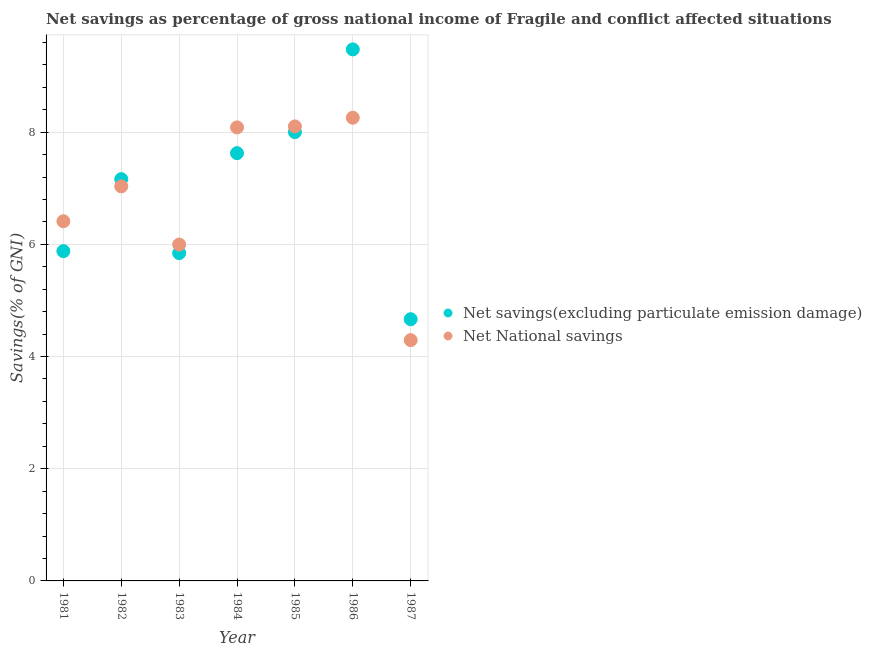Is the number of dotlines equal to the number of legend labels?
Offer a very short reply. Yes. What is the net savings(excluding particulate emission damage) in 1987?
Your answer should be compact. 4.67. Across all years, what is the maximum net savings(excluding particulate emission damage)?
Ensure brevity in your answer.  9.48. Across all years, what is the minimum net savings(excluding particulate emission damage)?
Provide a succinct answer. 4.67. In which year was the net national savings maximum?
Make the answer very short. 1986. In which year was the net national savings minimum?
Give a very brief answer. 1987. What is the total net savings(excluding particulate emission damage) in the graph?
Keep it short and to the point. 48.66. What is the difference between the net national savings in 1986 and that in 1987?
Offer a terse response. 3.96. What is the difference between the net national savings in 1986 and the net savings(excluding particulate emission damage) in 1984?
Keep it short and to the point. 0.63. What is the average net savings(excluding particulate emission damage) per year?
Offer a terse response. 6.95. In the year 1985, what is the difference between the net savings(excluding particulate emission damage) and net national savings?
Offer a terse response. -0.1. What is the ratio of the net national savings in 1981 to that in 1985?
Your answer should be very brief. 0.79. Is the difference between the net savings(excluding particulate emission damage) in 1982 and 1985 greater than the difference between the net national savings in 1982 and 1985?
Your answer should be compact. Yes. What is the difference between the highest and the second highest net savings(excluding particulate emission damage)?
Keep it short and to the point. 1.47. What is the difference between the highest and the lowest net savings(excluding particulate emission damage)?
Keep it short and to the point. 4.81. In how many years, is the net national savings greater than the average net national savings taken over all years?
Offer a very short reply. 4. Is the sum of the net savings(excluding particulate emission damage) in 1982 and 1984 greater than the maximum net national savings across all years?
Your answer should be compact. Yes. Does the net national savings monotonically increase over the years?
Offer a terse response. No. Is the net national savings strictly greater than the net savings(excluding particulate emission damage) over the years?
Make the answer very short. No. Is the net national savings strictly less than the net savings(excluding particulate emission damage) over the years?
Make the answer very short. No. How many dotlines are there?
Offer a very short reply. 2. How many years are there in the graph?
Your answer should be very brief. 7. Where does the legend appear in the graph?
Keep it short and to the point. Center right. How are the legend labels stacked?
Give a very brief answer. Vertical. What is the title of the graph?
Your answer should be compact. Net savings as percentage of gross national income of Fragile and conflict affected situations. Does "Residents" appear as one of the legend labels in the graph?
Ensure brevity in your answer.  No. What is the label or title of the X-axis?
Your answer should be compact. Year. What is the label or title of the Y-axis?
Ensure brevity in your answer.  Savings(% of GNI). What is the Savings(% of GNI) of Net savings(excluding particulate emission damage) in 1981?
Provide a succinct answer. 5.88. What is the Savings(% of GNI) in Net National savings in 1981?
Make the answer very short. 6.41. What is the Savings(% of GNI) of Net savings(excluding particulate emission damage) in 1982?
Provide a short and direct response. 7.16. What is the Savings(% of GNI) in Net National savings in 1982?
Offer a terse response. 7.03. What is the Savings(% of GNI) in Net savings(excluding particulate emission damage) in 1983?
Offer a terse response. 5.84. What is the Savings(% of GNI) of Net National savings in 1983?
Your response must be concise. 6. What is the Savings(% of GNI) of Net savings(excluding particulate emission damage) in 1984?
Give a very brief answer. 7.63. What is the Savings(% of GNI) in Net National savings in 1984?
Your answer should be compact. 8.09. What is the Savings(% of GNI) of Net savings(excluding particulate emission damage) in 1985?
Your answer should be compact. 8. What is the Savings(% of GNI) in Net National savings in 1985?
Provide a short and direct response. 8.1. What is the Savings(% of GNI) of Net savings(excluding particulate emission damage) in 1986?
Provide a short and direct response. 9.48. What is the Savings(% of GNI) of Net National savings in 1986?
Your response must be concise. 8.26. What is the Savings(% of GNI) of Net savings(excluding particulate emission damage) in 1987?
Provide a short and direct response. 4.67. What is the Savings(% of GNI) of Net National savings in 1987?
Make the answer very short. 4.29. Across all years, what is the maximum Savings(% of GNI) in Net savings(excluding particulate emission damage)?
Your response must be concise. 9.48. Across all years, what is the maximum Savings(% of GNI) in Net National savings?
Give a very brief answer. 8.26. Across all years, what is the minimum Savings(% of GNI) in Net savings(excluding particulate emission damage)?
Give a very brief answer. 4.67. Across all years, what is the minimum Savings(% of GNI) in Net National savings?
Ensure brevity in your answer.  4.29. What is the total Savings(% of GNI) in Net savings(excluding particulate emission damage) in the graph?
Your response must be concise. 48.66. What is the total Savings(% of GNI) in Net National savings in the graph?
Make the answer very short. 48.18. What is the difference between the Savings(% of GNI) in Net savings(excluding particulate emission damage) in 1981 and that in 1982?
Give a very brief answer. -1.28. What is the difference between the Savings(% of GNI) in Net National savings in 1981 and that in 1982?
Your response must be concise. -0.62. What is the difference between the Savings(% of GNI) of Net savings(excluding particulate emission damage) in 1981 and that in 1983?
Make the answer very short. 0.03. What is the difference between the Savings(% of GNI) in Net National savings in 1981 and that in 1983?
Your answer should be compact. 0.41. What is the difference between the Savings(% of GNI) in Net savings(excluding particulate emission damage) in 1981 and that in 1984?
Your response must be concise. -1.75. What is the difference between the Savings(% of GNI) of Net National savings in 1981 and that in 1984?
Provide a succinct answer. -1.67. What is the difference between the Savings(% of GNI) in Net savings(excluding particulate emission damage) in 1981 and that in 1985?
Offer a very short reply. -2.12. What is the difference between the Savings(% of GNI) in Net National savings in 1981 and that in 1985?
Your response must be concise. -1.69. What is the difference between the Savings(% of GNI) in Net savings(excluding particulate emission damage) in 1981 and that in 1986?
Your response must be concise. -3.6. What is the difference between the Savings(% of GNI) in Net National savings in 1981 and that in 1986?
Keep it short and to the point. -1.85. What is the difference between the Savings(% of GNI) of Net savings(excluding particulate emission damage) in 1981 and that in 1987?
Ensure brevity in your answer.  1.21. What is the difference between the Savings(% of GNI) in Net National savings in 1981 and that in 1987?
Keep it short and to the point. 2.12. What is the difference between the Savings(% of GNI) in Net savings(excluding particulate emission damage) in 1982 and that in 1983?
Your answer should be very brief. 1.32. What is the difference between the Savings(% of GNI) of Net National savings in 1982 and that in 1983?
Provide a short and direct response. 1.04. What is the difference between the Savings(% of GNI) in Net savings(excluding particulate emission damage) in 1982 and that in 1984?
Give a very brief answer. -0.46. What is the difference between the Savings(% of GNI) in Net National savings in 1982 and that in 1984?
Provide a succinct answer. -1.05. What is the difference between the Savings(% of GNI) of Net savings(excluding particulate emission damage) in 1982 and that in 1985?
Your answer should be very brief. -0.84. What is the difference between the Savings(% of GNI) of Net National savings in 1982 and that in 1985?
Your answer should be very brief. -1.07. What is the difference between the Savings(% of GNI) of Net savings(excluding particulate emission damage) in 1982 and that in 1986?
Keep it short and to the point. -2.31. What is the difference between the Savings(% of GNI) of Net National savings in 1982 and that in 1986?
Your response must be concise. -1.22. What is the difference between the Savings(% of GNI) of Net savings(excluding particulate emission damage) in 1982 and that in 1987?
Make the answer very short. 2.5. What is the difference between the Savings(% of GNI) of Net National savings in 1982 and that in 1987?
Keep it short and to the point. 2.74. What is the difference between the Savings(% of GNI) in Net savings(excluding particulate emission damage) in 1983 and that in 1984?
Your answer should be compact. -1.78. What is the difference between the Savings(% of GNI) of Net National savings in 1983 and that in 1984?
Make the answer very short. -2.09. What is the difference between the Savings(% of GNI) of Net savings(excluding particulate emission damage) in 1983 and that in 1985?
Your answer should be very brief. -2.16. What is the difference between the Savings(% of GNI) of Net National savings in 1983 and that in 1985?
Your answer should be very brief. -2.11. What is the difference between the Savings(% of GNI) of Net savings(excluding particulate emission damage) in 1983 and that in 1986?
Your answer should be compact. -3.63. What is the difference between the Savings(% of GNI) of Net National savings in 1983 and that in 1986?
Ensure brevity in your answer.  -2.26. What is the difference between the Savings(% of GNI) of Net savings(excluding particulate emission damage) in 1983 and that in 1987?
Provide a succinct answer. 1.18. What is the difference between the Savings(% of GNI) of Net National savings in 1983 and that in 1987?
Your answer should be very brief. 1.7. What is the difference between the Savings(% of GNI) of Net savings(excluding particulate emission damage) in 1984 and that in 1985?
Your response must be concise. -0.38. What is the difference between the Savings(% of GNI) in Net National savings in 1984 and that in 1985?
Ensure brevity in your answer.  -0.02. What is the difference between the Savings(% of GNI) in Net savings(excluding particulate emission damage) in 1984 and that in 1986?
Give a very brief answer. -1.85. What is the difference between the Savings(% of GNI) of Net National savings in 1984 and that in 1986?
Offer a very short reply. -0.17. What is the difference between the Savings(% of GNI) of Net savings(excluding particulate emission damage) in 1984 and that in 1987?
Provide a succinct answer. 2.96. What is the difference between the Savings(% of GNI) of Net National savings in 1984 and that in 1987?
Provide a succinct answer. 3.79. What is the difference between the Savings(% of GNI) in Net savings(excluding particulate emission damage) in 1985 and that in 1986?
Give a very brief answer. -1.47. What is the difference between the Savings(% of GNI) in Net National savings in 1985 and that in 1986?
Your answer should be compact. -0.15. What is the difference between the Savings(% of GNI) in Net savings(excluding particulate emission damage) in 1985 and that in 1987?
Offer a very short reply. 3.34. What is the difference between the Savings(% of GNI) in Net National savings in 1985 and that in 1987?
Give a very brief answer. 3.81. What is the difference between the Savings(% of GNI) in Net savings(excluding particulate emission damage) in 1986 and that in 1987?
Ensure brevity in your answer.  4.81. What is the difference between the Savings(% of GNI) of Net National savings in 1986 and that in 1987?
Provide a succinct answer. 3.96. What is the difference between the Savings(% of GNI) in Net savings(excluding particulate emission damage) in 1981 and the Savings(% of GNI) in Net National savings in 1982?
Provide a short and direct response. -1.16. What is the difference between the Savings(% of GNI) of Net savings(excluding particulate emission damage) in 1981 and the Savings(% of GNI) of Net National savings in 1983?
Ensure brevity in your answer.  -0.12. What is the difference between the Savings(% of GNI) in Net savings(excluding particulate emission damage) in 1981 and the Savings(% of GNI) in Net National savings in 1984?
Keep it short and to the point. -2.21. What is the difference between the Savings(% of GNI) of Net savings(excluding particulate emission damage) in 1981 and the Savings(% of GNI) of Net National savings in 1985?
Your answer should be compact. -2.22. What is the difference between the Savings(% of GNI) of Net savings(excluding particulate emission damage) in 1981 and the Savings(% of GNI) of Net National savings in 1986?
Your answer should be compact. -2.38. What is the difference between the Savings(% of GNI) in Net savings(excluding particulate emission damage) in 1981 and the Savings(% of GNI) in Net National savings in 1987?
Offer a very short reply. 1.59. What is the difference between the Savings(% of GNI) in Net savings(excluding particulate emission damage) in 1982 and the Savings(% of GNI) in Net National savings in 1983?
Your response must be concise. 1.17. What is the difference between the Savings(% of GNI) in Net savings(excluding particulate emission damage) in 1982 and the Savings(% of GNI) in Net National savings in 1984?
Ensure brevity in your answer.  -0.92. What is the difference between the Savings(% of GNI) in Net savings(excluding particulate emission damage) in 1982 and the Savings(% of GNI) in Net National savings in 1985?
Make the answer very short. -0.94. What is the difference between the Savings(% of GNI) in Net savings(excluding particulate emission damage) in 1982 and the Savings(% of GNI) in Net National savings in 1986?
Provide a succinct answer. -1.09. What is the difference between the Savings(% of GNI) in Net savings(excluding particulate emission damage) in 1982 and the Savings(% of GNI) in Net National savings in 1987?
Offer a very short reply. 2.87. What is the difference between the Savings(% of GNI) in Net savings(excluding particulate emission damage) in 1983 and the Savings(% of GNI) in Net National savings in 1984?
Your answer should be very brief. -2.24. What is the difference between the Savings(% of GNI) of Net savings(excluding particulate emission damage) in 1983 and the Savings(% of GNI) of Net National savings in 1985?
Your answer should be very brief. -2.26. What is the difference between the Savings(% of GNI) in Net savings(excluding particulate emission damage) in 1983 and the Savings(% of GNI) in Net National savings in 1986?
Give a very brief answer. -2.41. What is the difference between the Savings(% of GNI) in Net savings(excluding particulate emission damage) in 1983 and the Savings(% of GNI) in Net National savings in 1987?
Provide a short and direct response. 1.55. What is the difference between the Savings(% of GNI) of Net savings(excluding particulate emission damage) in 1984 and the Savings(% of GNI) of Net National savings in 1985?
Make the answer very short. -0.48. What is the difference between the Savings(% of GNI) in Net savings(excluding particulate emission damage) in 1984 and the Savings(% of GNI) in Net National savings in 1986?
Provide a succinct answer. -0.63. What is the difference between the Savings(% of GNI) in Net savings(excluding particulate emission damage) in 1984 and the Savings(% of GNI) in Net National savings in 1987?
Provide a short and direct response. 3.33. What is the difference between the Savings(% of GNI) in Net savings(excluding particulate emission damage) in 1985 and the Savings(% of GNI) in Net National savings in 1986?
Your answer should be very brief. -0.26. What is the difference between the Savings(% of GNI) in Net savings(excluding particulate emission damage) in 1985 and the Savings(% of GNI) in Net National savings in 1987?
Your response must be concise. 3.71. What is the difference between the Savings(% of GNI) of Net savings(excluding particulate emission damage) in 1986 and the Savings(% of GNI) of Net National savings in 1987?
Keep it short and to the point. 5.18. What is the average Savings(% of GNI) in Net savings(excluding particulate emission damage) per year?
Keep it short and to the point. 6.95. What is the average Savings(% of GNI) of Net National savings per year?
Offer a terse response. 6.88. In the year 1981, what is the difference between the Savings(% of GNI) of Net savings(excluding particulate emission damage) and Savings(% of GNI) of Net National savings?
Provide a succinct answer. -0.53. In the year 1982, what is the difference between the Savings(% of GNI) in Net savings(excluding particulate emission damage) and Savings(% of GNI) in Net National savings?
Offer a terse response. 0.13. In the year 1983, what is the difference between the Savings(% of GNI) in Net savings(excluding particulate emission damage) and Savings(% of GNI) in Net National savings?
Offer a very short reply. -0.15. In the year 1984, what is the difference between the Savings(% of GNI) of Net savings(excluding particulate emission damage) and Savings(% of GNI) of Net National savings?
Give a very brief answer. -0.46. In the year 1985, what is the difference between the Savings(% of GNI) of Net savings(excluding particulate emission damage) and Savings(% of GNI) of Net National savings?
Offer a very short reply. -0.1. In the year 1986, what is the difference between the Savings(% of GNI) in Net savings(excluding particulate emission damage) and Savings(% of GNI) in Net National savings?
Offer a terse response. 1.22. In the year 1987, what is the difference between the Savings(% of GNI) of Net savings(excluding particulate emission damage) and Savings(% of GNI) of Net National savings?
Make the answer very short. 0.37. What is the ratio of the Savings(% of GNI) in Net savings(excluding particulate emission damage) in 1981 to that in 1982?
Provide a succinct answer. 0.82. What is the ratio of the Savings(% of GNI) in Net National savings in 1981 to that in 1982?
Your answer should be very brief. 0.91. What is the ratio of the Savings(% of GNI) in Net savings(excluding particulate emission damage) in 1981 to that in 1983?
Offer a terse response. 1.01. What is the ratio of the Savings(% of GNI) in Net National savings in 1981 to that in 1983?
Offer a very short reply. 1.07. What is the ratio of the Savings(% of GNI) in Net savings(excluding particulate emission damage) in 1981 to that in 1984?
Your answer should be compact. 0.77. What is the ratio of the Savings(% of GNI) in Net National savings in 1981 to that in 1984?
Offer a very short reply. 0.79. What is the ratio of the Savings(% of GNI) of Net savings(excluding particulate emission damage) in 1981 to that in 1985?
Give a very brief answer. 0.73. What is the ratio of the Savings(% of GNI) of Net National savings in 1981 to that in 1985?
Offer a very short reply. 0.79. What is the ratio of the Savings(% of GNI) in Net savings(excluding particulate emission damage) in 1981 to that in 1986?
Provide a succinct answer. 0.62. What is the ratio of the Savings(% of GNI) of Net National savings in 1981 to that in 1986?
Offer a terse response. 0.78. What is the ratio of the Savings(% of GNI) in Net savings(excluding particulate emission damage) in 1981 to that in 1987?
Give a very brief answer. 1.26. What is the ratio of the Savings(% of GNI) in Net National savings in 1981 to that in 1987?
Make the answer very short. 1.49. What is the ratio of the Savings(% of GNI) in Net savings(excluding particulate emission damage) in 1982 to that in 1983?
Provide a short and direct response. 1.23. What is the ratio of the Savings(% of GNI) in Net National savings in 1982 to that in 1983?
Make the answer very short. 1.17. What is the ratio of the Savings(% of GNI) of Net savings(excluding particulate emission damage) in 1982 to that in 1984?
Provide a short and direct response. 0.94. What is the ratio of the Savings(% of GNI) of Net National savings in 1982 to that in 1984?
Your response must be concise. 0.87. What is the ratio of the Savings(% of GNI) in Net savings(excluding particulate emission damage) in 1982 to that in 1985?
Offer a terse response. 0.9. What is the ratio of the Savings(% of GNI) of Net National savings in 1982 to that in 1985?
Your answer should be compact. 0.87. What is the ratio of the Savings(% of GNI) of Net savings(excluding particulate emission damage) in 1982 to that in 1986?
Provide a succinct answer. 0.76. What is the ratio of the Savings(% of GNI) of Net National savings in 1982 to that in 1986?
Provide a short and direct response. 0.85. What is the ratio of the Savings(% of GNI) in Net savings(excluding particulate emission damage) in 1982 to that in 1987?
Keep it short and to the point. 1.54. What is the ratio of the Savings(% of GNI) of Net National savings in 1982 to that in 1987?
Your answer should be very brief. 1.64. What is the ratio of the Savings(% of GNI) in Net savings(excluding particulate emission damage) in 1983 to that in 1984?
Give a very brief answer. 0.77. What is the ratio of the Savings(% of GNI) of Net National savings in 1983 to that in 1984?
Provide a short and direct response. 0.74. What is the ratio of the Savings(% of GNI) of Net savings(excluding particulate emission damage) in 1983 to that in 1985?
Ensure brevity in your answer.  0.73. What is the ratio of the Savings(% of GNI) of Net National savings in 1983 to that in 1985?
Your response must be concise. 0.74. What is the ratio of the Savings(% of GNI) in Net savings(excluding particulate emission damage) in 1983 to that in 1986?
Provide a succinct answer. 0.62. What is the ratio of the Savings(% of GNI) in Net National savings in 1983 to that in 1986?
Provide a short and direct response. 0.73. What is the ratio of the Savings(% of GNI) of Net savings(excluding particulate emission damage) in 1983 to that in 1987?
Offer a very short reply. 1.25. What is the ratio of the Savings(% of GNI) of Net National savings in 1983 to that in 1987?
Ensure brevity in your answer.  1.4. What is the ratio of the Savings(% of GNI) of Net savings(excluding particulate emission damage) in 1984 to that in 1985?
Offer a terse response. 0.95. What is the ratio of the Savings(% of GNI) of Net National savings in 1984 to that in 1985?
Offer a terse response. 1. What is the ratio of the Savings(% of GNI) of Net savings(excluding particulate emission damage) in 1984 to that in 1986?
Offer a very short reply. 0.8. What is the ratio of the Savings(% of GNI) in Net National savings in 1984 to that in 1986?
Your response must be concise. 0.98. What is the ratio of the Savings(% of GNI) in Net savings(excluding particulate emission damage) in 1984 to that in 1987?
Keep it short and to the point. 1.63. What is the ratio of the Savings(% of GNI) of Net National savings in 1984 to that in 1987?
Make the answer very short. 1.88. What is the ratio of the Savings(% of GNI) in Net savings(excluding particulate emission damage) in 1985 to that in 1986?
Make the answer very short. 0.84. What is the ratio of the Savings(% of GNI) in Net National savings in 1985 to that in 1986?
Make the answer very short. 0.98. What is the ratio of the Savings(% of GNI) in Net savings(excluding particulate emission damage) in 1985 to that in 1987?
Keep it short and to the point. 1.72. What is the ratio of the Savings(% of GNI) of Net National savings in 1985 to that in 1987?
Ensure brevity in your answer.  1.89. What is the ratio of the Savings(% of GNI) of Net savings(excluding particulate emission damage) in 1986 to that in 1987?
Provide a succinct answer. 2.03. What is the ratio of the Savings(% of GNI) in Net National savings in 1986 to that in 1987?
Your response must be concise. 1.92. What is the difference between the highest and the second highest Savings(% of GNI) of Net savings(excluding particulate emission damage)?
Your response must be concise. 1.47. What is the difference between the highest and the second highest Savings(% of GNI) in Net National savings?
Make the answer very short. 0.15. What is the difference between the highest and the lowest Savings(% of GNI) in Net savings(excluding particulate emission damage)?
Provide a short and direct response. 4.81. What is the difference between the highest and the lowest Savings(% of GNI) in Net National savings?
Your response must be concise. 3.96. 